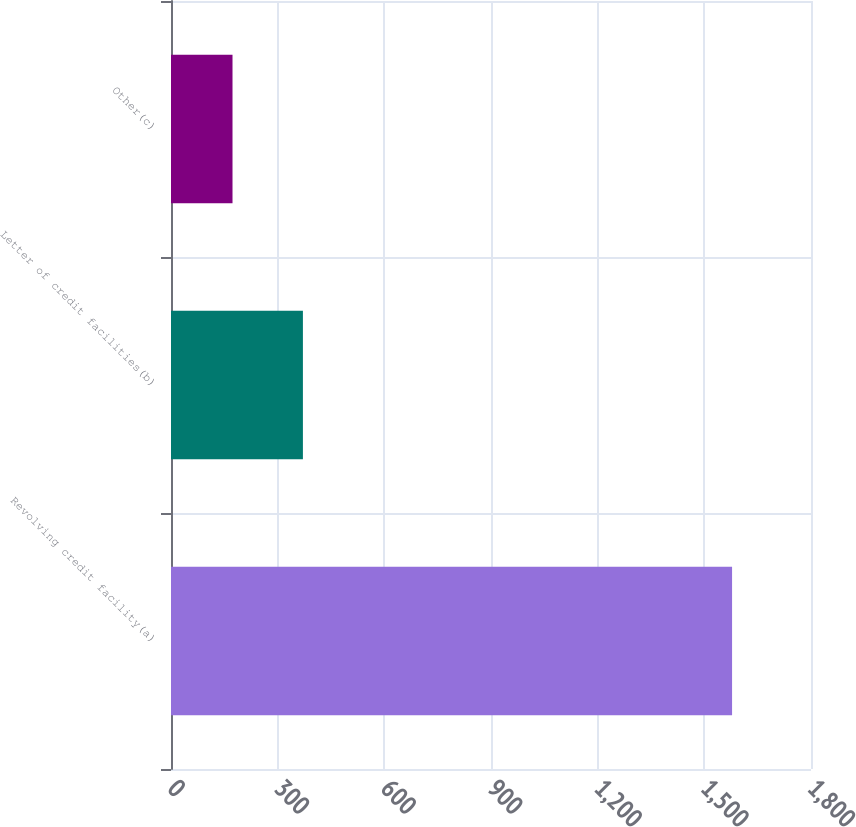Convert chart to OTSL. <chart><loc_0><loc_0><loc_500><loc_500><bar_chart><fcel>Revolving credit facility(a)<fcel>Letter of credit facilities(b)<fcel>Other(c)<nl><fcel>1578<fcel>371<fcel>173<nl></chart> 